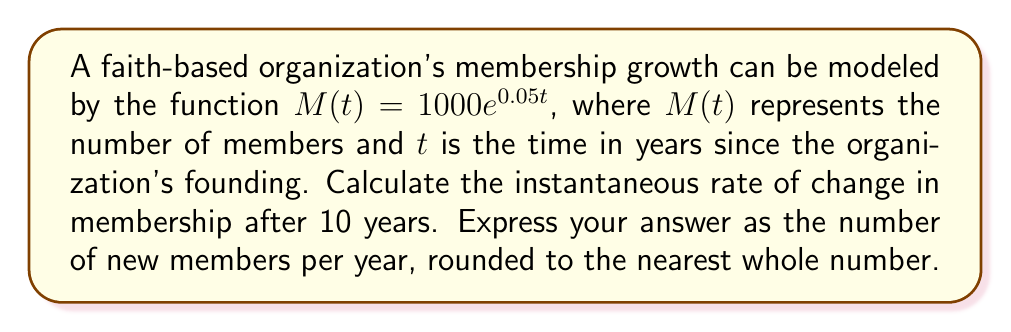Teach me how to tackle this problem. To find the instantaneous rate of change, we need to calculate the derivative of the membership function $M(t)$ and evaluate it at $t = 10$.

Step 1: Find the derivative of $M(t)$.
$$\frac{d}{dt}M(t) = \frac{d}{dt}(1000e^{0.05t})$$
Using the chain rule, we get:
$$M'(t) = 1000 \cdot 0.05e^{0.05t} = 50e^{0.05t}$$

Step 2: Evaluate $M'(t)$ at $t = 10$.
$$M'(10) = 50e^{0.05 \cdot 10} = 50e^{0.5}$$

Step 3: Calculate the value.
$$M'(10) = 50 \cdot e^{0.5} \approx 82.44$$

Step 4: Round to the nearest whole number.
$$M'(10) \approx 82$$

This result represents the instantaneous rate of change in membership after 10 years, or the number of new members per year at that time.
Answer: 82 new members per year 